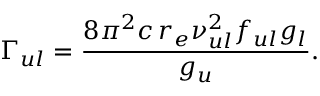<formula> <loc_0><loc_0><loc_500><loc_500>\Gamma _ { u l } = \frac { 8 \pi ^ { 2 } c \, r _ { e } \nu _ { u l } ^ { 2 } f _ { u l } g _ { l } } { g _ { u } } .</formula> 